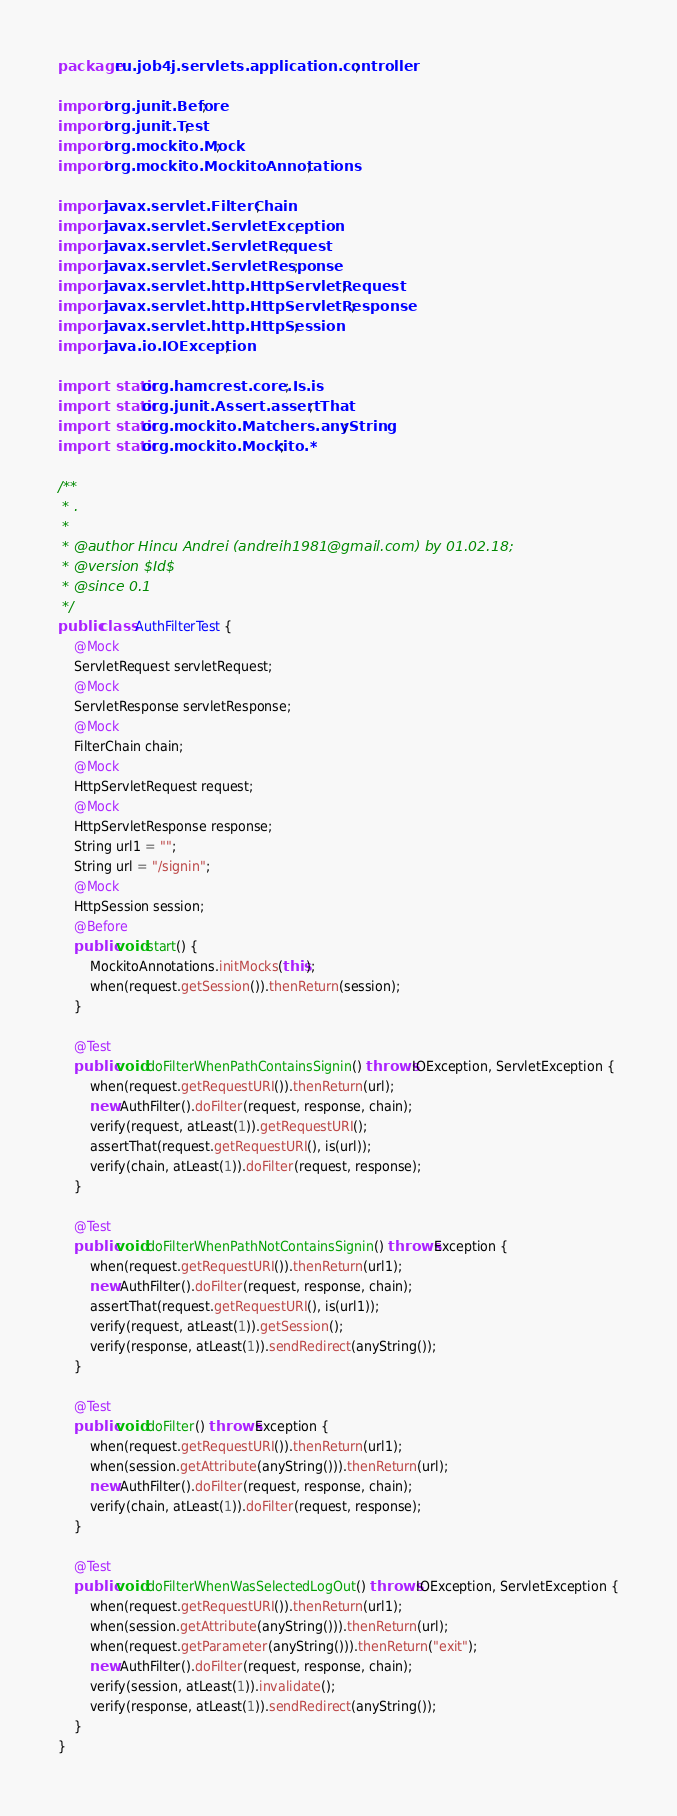<code> <loc_0><loc_0><loc_500><loc_500><_Java_>package ru.job4j.servlets.application.controller;

import org.junit.Before;
import org.junit.Test;
import org.mockito.Mock;
import org.mockito.MockitoAnnotations;

import javax.servlet.FilterChain;
import javax.servlet.ServletException;
import javax.servlet.ServletRequest;
import javax.servlet.ServletResponse;
import javax.servlet.http.HttpServletRequest;
import javax.servlet.http.HttpServletResponse;
import javax.servlet.http.HttpSession;
import java.io.IOException;

import static org.hamcrest.core.Is.is;
import static org.junit.Assert.assertThat;
import static org.mockito.Matchers.anyString;
import static org.mockito.Mockito.*;

/**
 * .
 *
 * @author Hincu Andrei (andreih1981@gmail.com) by 01.02.18;
 * @version $Id$
 * @since 0.1
 */
public class AuthFilterTest {
    @Mock
    ServletRequest servletRequest;
    @Mock
    ServletResponse servletResponse;
    @Mock
    FilterChain chain;
    @Mock
    HttpServletRequest request;
    @Mock
    HttpServletResponse response;
    String url1 = "";
    String url = "/signin";
    @Mock
    HttpSession session;
    @Before
    public void start() {
        MockitoAnnotations.initMocks(this);
        when(request.getSession()).thenReturn(session);
    }

    @Test
    public void doFilterWhenPathContainsSignin() throws IOException, ServletException {
        when(request.getRequestURI()).thenReturn(url);
        new AuthFilter().doFilter(request, response, chain);
        verify(request, atLeast(1)).getRequestURI();
        assertThat(request.getRequestURI(), is(url));
        verify(chain, atLeast(1)).doFilter(request, response);
    }

    @Test
    public void doFilterWhenPathNotContainsSignin() throws Exception {
        when(request.getRequestURI()).thenReturn(url1);
        new AuthFilter().doFilter(request, response, chain);
        assertThat(request.getRequestURI(), is(url1));
        verify(request, atLeast(1)).getSession();
        verify(response, atLeast(1)).sendRedirect(anyString());
    }

    @Test
    public void doFilter() throws Exception {
        when(request.getRequestURI()).thenReturn(url1);
        when(session.getAttribute(anyString())).thenReturn(url);
        new AuthFilter().doFilter(request, response, chain);
        verify(chain, atLeast(1)).doFilter(request, response);
    }

    @Test
    public void doFilterWhenWasSelectedLogOut() throws IOException, ServletException {
        when(request.getRequestURI()).thenReturn(url1);
        when(session.getAttribute(anyString())).thenReturn(url);
        when(request.getParameter(anyString())).thenReturn("exit");
        new AuthFilter().doFilter(request, response, chain);
        verify(session, atLeast(1)).invalidate();
        verify(response, atLeast(1)).sendRedirect(anyString());
    }
}</code> 